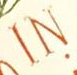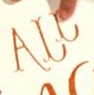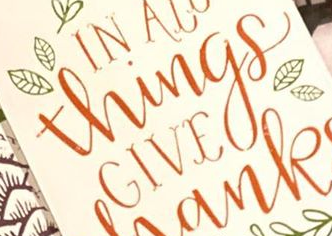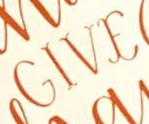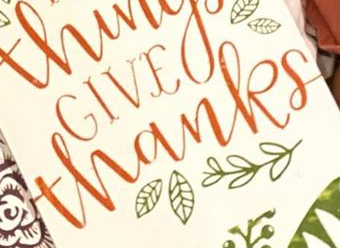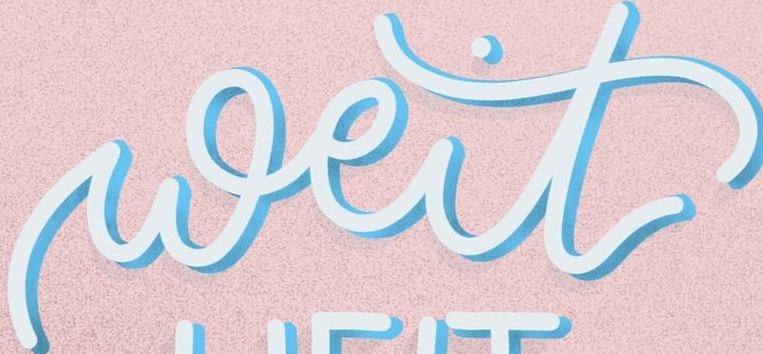What text is displayed in these images sequentially, separated by a semicolon? IN; ALL; Things; GIVE; thanks; weit 